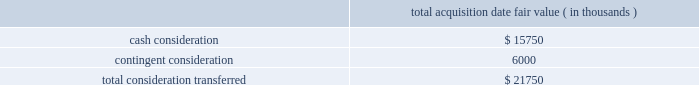Abiomed , inc .
And subsidiaries notes to consolidated financial statements 2014 ( continued ) note 3 .
Acquisitions ( continued ) including the revenues of third-party licensees , or ( ii ) the company 2019s sale of ( a ) ecp , ( b ) all or substantially all of ecp 2019s assets , or ( c ) certain of ecp 2019s patent rights , the company will pay to syscore the lesser of ( x ) one-half of the profits earned from such sale described in the foregoing item ( ii ) , after accounting for the costs of acquiring and operating ecp , or ( y ) $ 15.0 million ( less any previous milestone payment ) .
Ecp 2019s acquisition of ais gmbh aachen innovative solutions in connection with the company 2019s acquisition of ecp , ecp acquired all of the share capital of ais gmbh aachen innovative solutions ( 201cais 201d ) , a limited liability company incorporated in germany , pursuant to a share purchase agreement dated as of june 30 , 2014 , by and among ecp and ais 2019s four individual shareholders .
Ais , based in aachen , germany , holds certain intellectual property useful to ecp 2019s business , and , prior to being acquired by ecp , had licensed such intellectual property to ecp .
The purchase price for the acquisition of ais 2019s share capital was approximately $ 2.8 million in cash , which was provided by the company , and the acquisition closed immediately prior to abiomed europe 2019s acquisition of ecp .
The share purchase agreement contains representations , warranties and closing conditions customary for transactions of its size and nature .
Purchase price allocation the acquisition of ecp and ais was accounted for as a business combination .
The purchase price for the acquisition has been allocated to the assets acquired and liabilities assumed based on their estimated fair values .
The acquisition-date fair value of the consideration transferred is as follows : acquisition date fair value ( in thousands ) .

For the ecp and ais transactions , what portion of the total consideration was paid immediately in cash? 
Computations: (15750 / 21750)
Answer: 0.72414. 